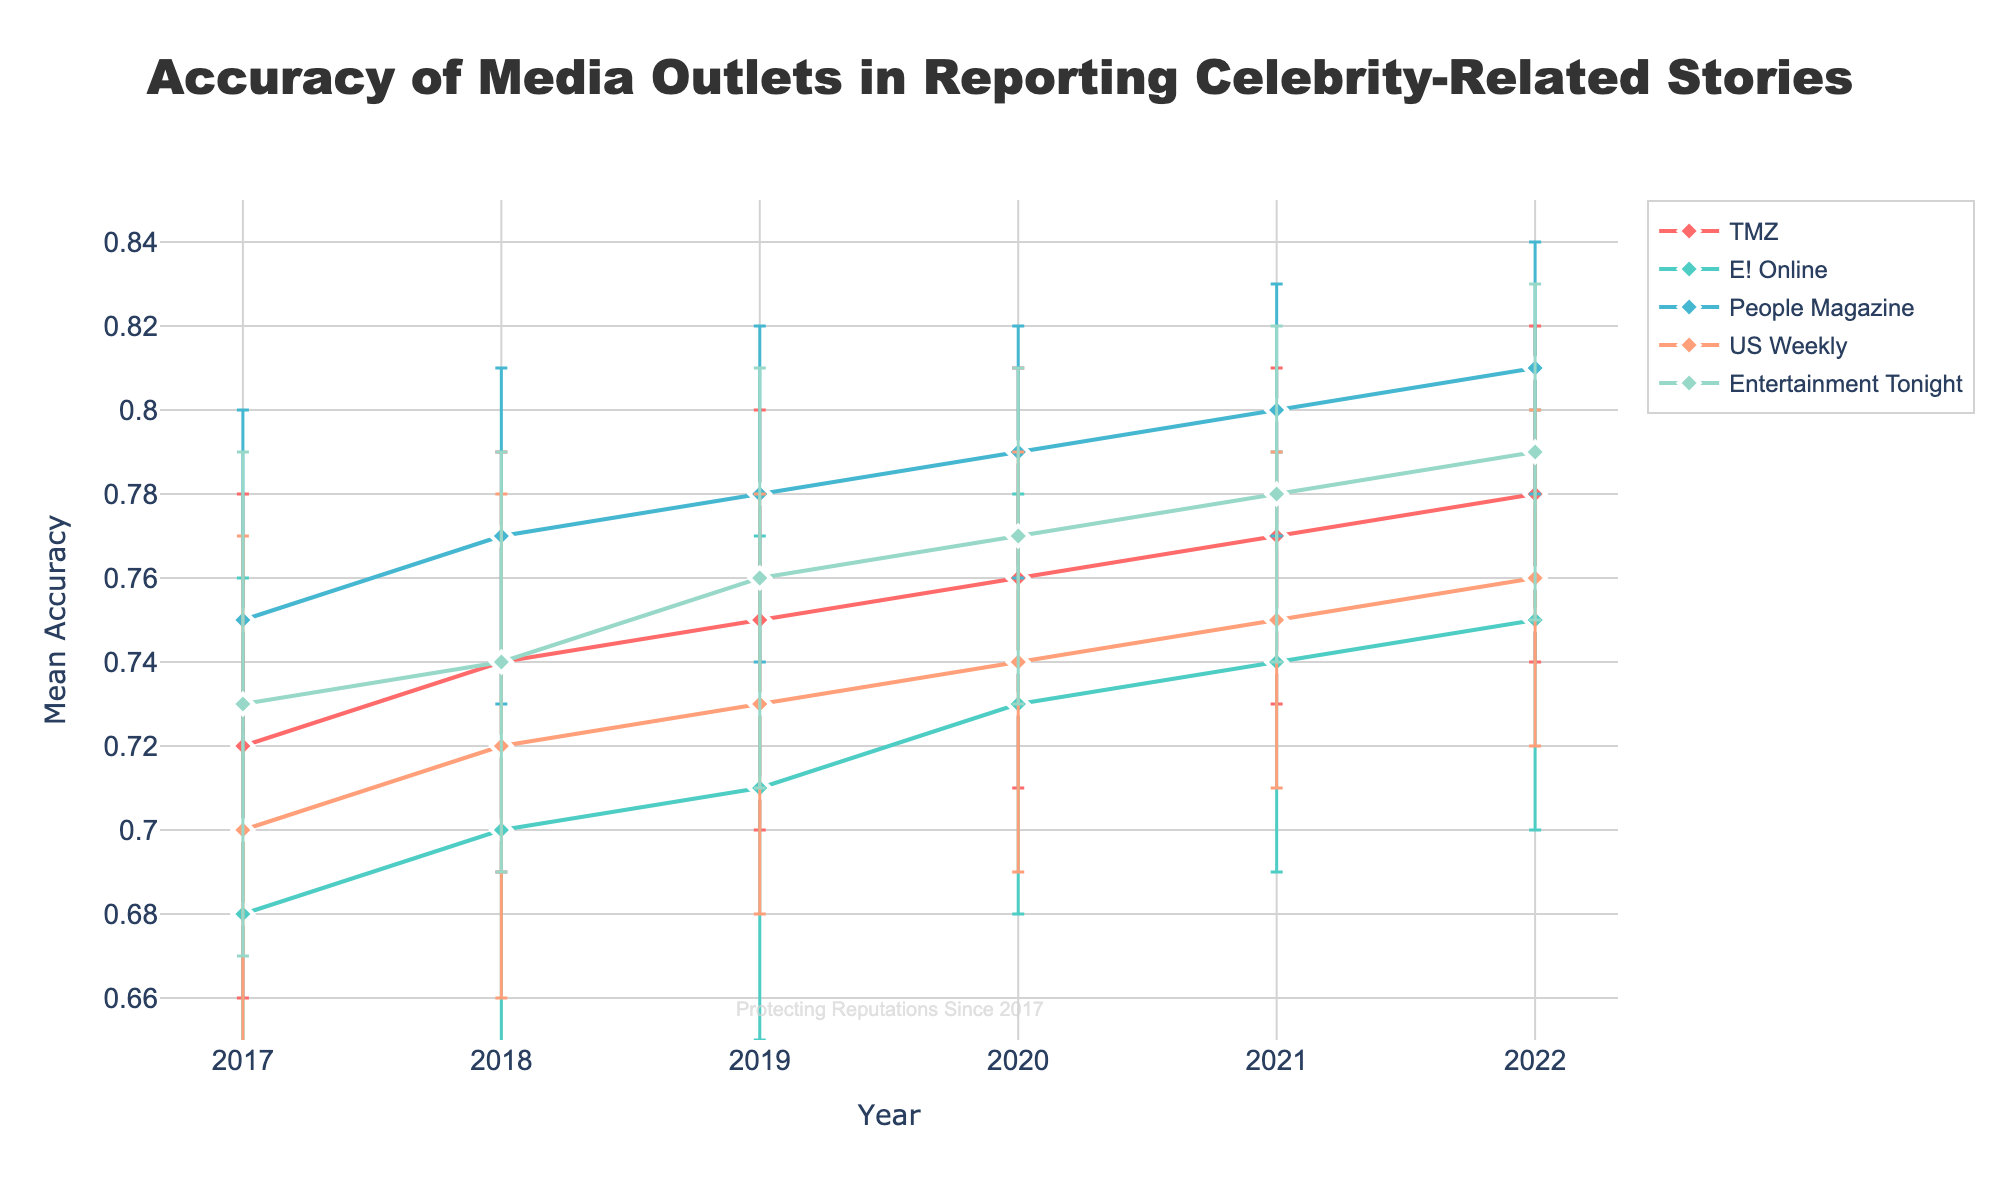What is the title of the plot? The title of the plot is prominently displayed at the top and reads 'Accuracy of Media Outlets in Reporting Celebrity-Related Stories'.
Answer: Accuracy of Media Outlets in Reporting Celebrity-Related Stories How many years of data are shown in the plot? The x-axis of the plot shows the years for which data is displayed. From the plot, it ranges from 2017 to 2022, inclusive.
Answer: 6 Which media outlet had the highest mean accuracy in 2022? By examining the data points for each media outlet in the year 2022, People Magazine has the highest mean accuracy with a value of 0.81.
Answer: People Magazine What is the range of mean accuracy values on the y-axis? The y-axis displays the range of mean accuracy values, starting from 0.65 to 0.85 as indicated by the axis labels.
Answer: 0.65 to 0.85 Which media outlet consistently improved the accuracy of their reporting each year from 2017 to 2022? Checking the trend lines of each media outlet from 2017 to 2022, TMZ shows a consistent improvement in mean accuracy every year.
Answer: TMZ How does the mean accuracy of Entertainment Tonight in 2020 compare to 2021? From the plot, the mean accuracy of Entertainment Tonight in 2020 is 0.77, and in 2021 it is 0.78. 0.77 is less than 0.78.
Answer: It increased What was the mean accuracy for US Weekly in 2019? By locating the data point for US Weekly in the year 2019 on the plot, the mean accuracy is observed to be 0.73.
Answer: 0.73 Which media outlet had the smallest error bars in 2020? Analyzing the length of error bars in 2020, People Magazine has the smallest error bars indicating the lowest standard deviation of 0.03.
Answer: People Magazine Between 2018 and 2019, which media outlet had the highest increase in mean accuracy and by how much? Reviewing the changes in mean accuracy between 2018 and 2019 for each media outlet: TMZ (0.01), E! Online (0.01), People Magazine (0.01), US Weekly (0.01), and Entertainment Tonight (0.02). Entertainment Tonight had the highest increase of 0.02.
Answer: Entertainment Tonight, 0.02 What is the watermark text on the plot? The watermark text is located towards the bottom of the plot and reads 'Protecting Reputations Since 2017'.
Answer: Protecting Reputations Since 2017 